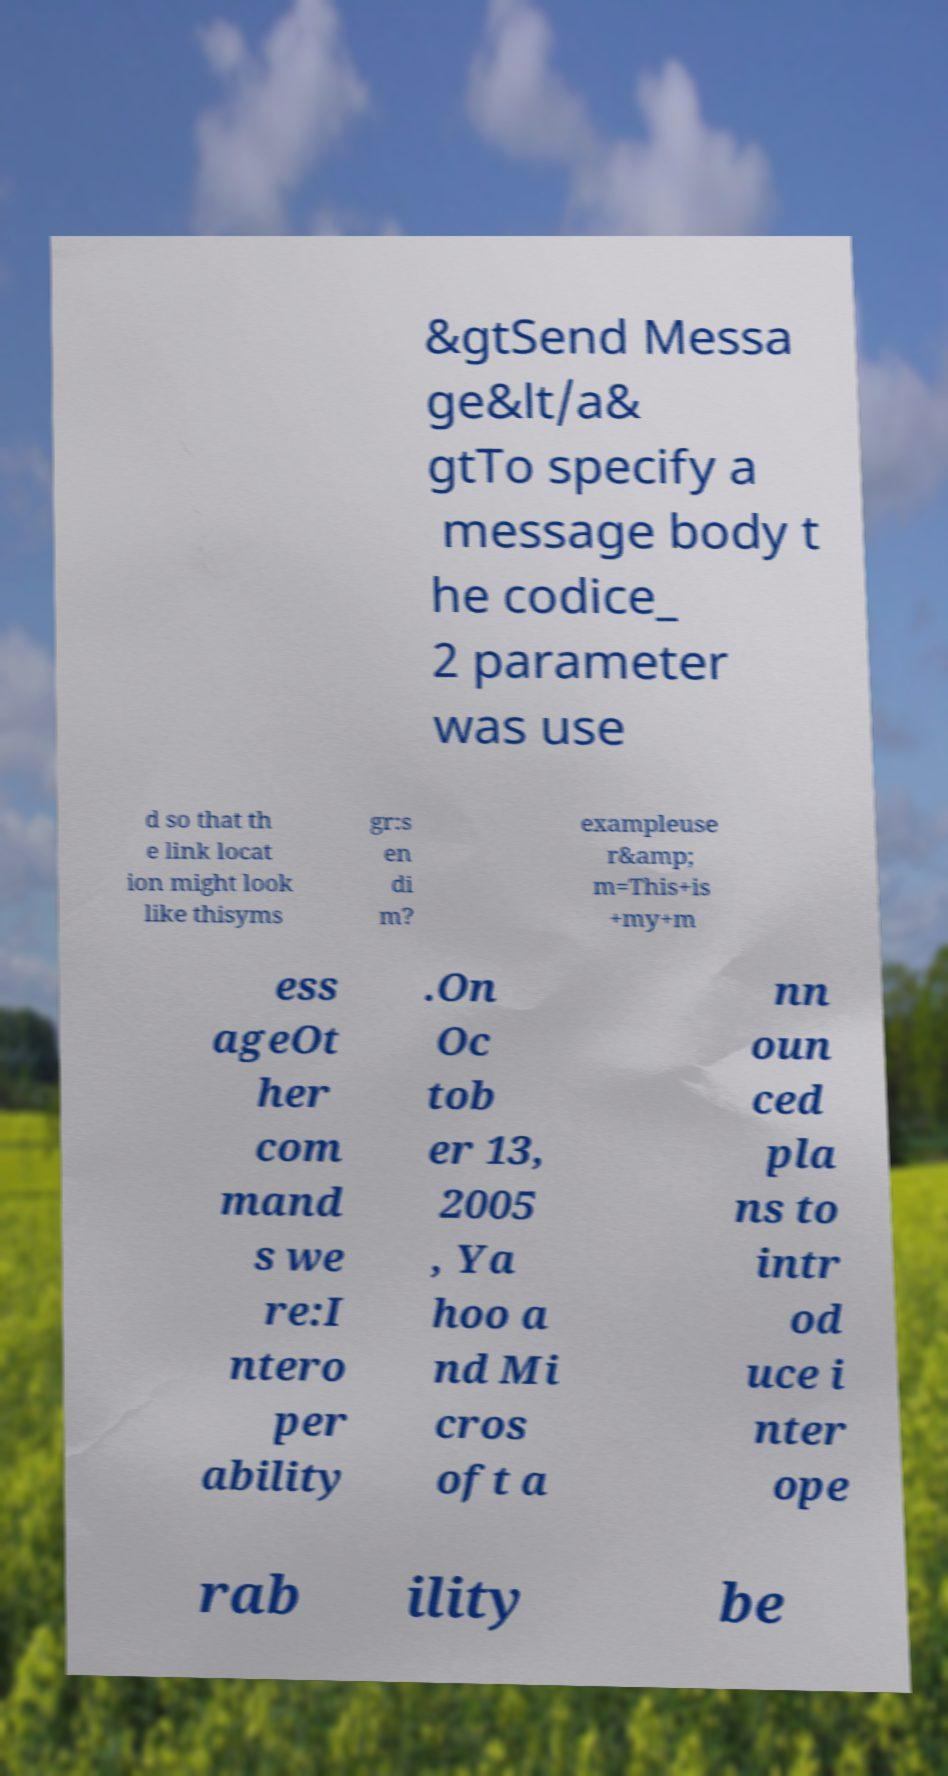Please identify and transcribe the text found in this image. &gtSend Messa ge&lt/a& gtTo specify a message body t he codice_ 2 parameter was use d so that th e link locat ion might look like thisyms gr:s en di m? exampleuse r&amp; m=This+is +my+m ess ageOt her com mand s we re:I ntero per ability .On Oc tob er 13, 2005 , Ya hoo a nd Mi cros oft a nn oun ced pla ns to intr od uce i nter ope rab ility be 